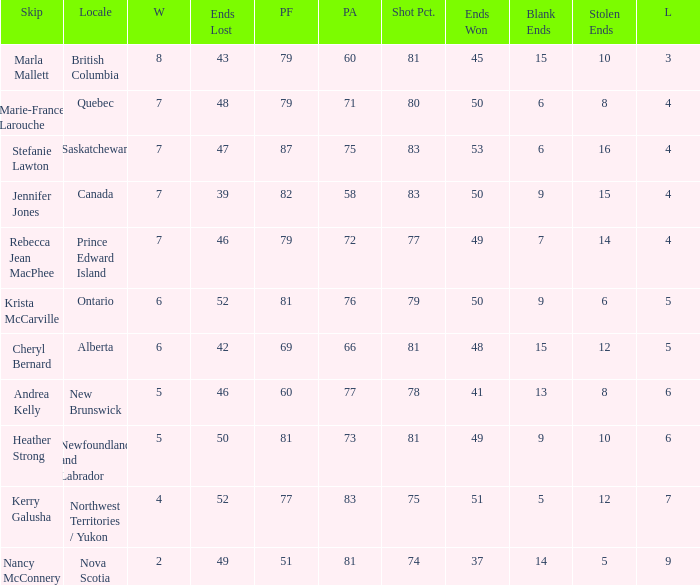Where was the shot pct 78? New Brunswick. 